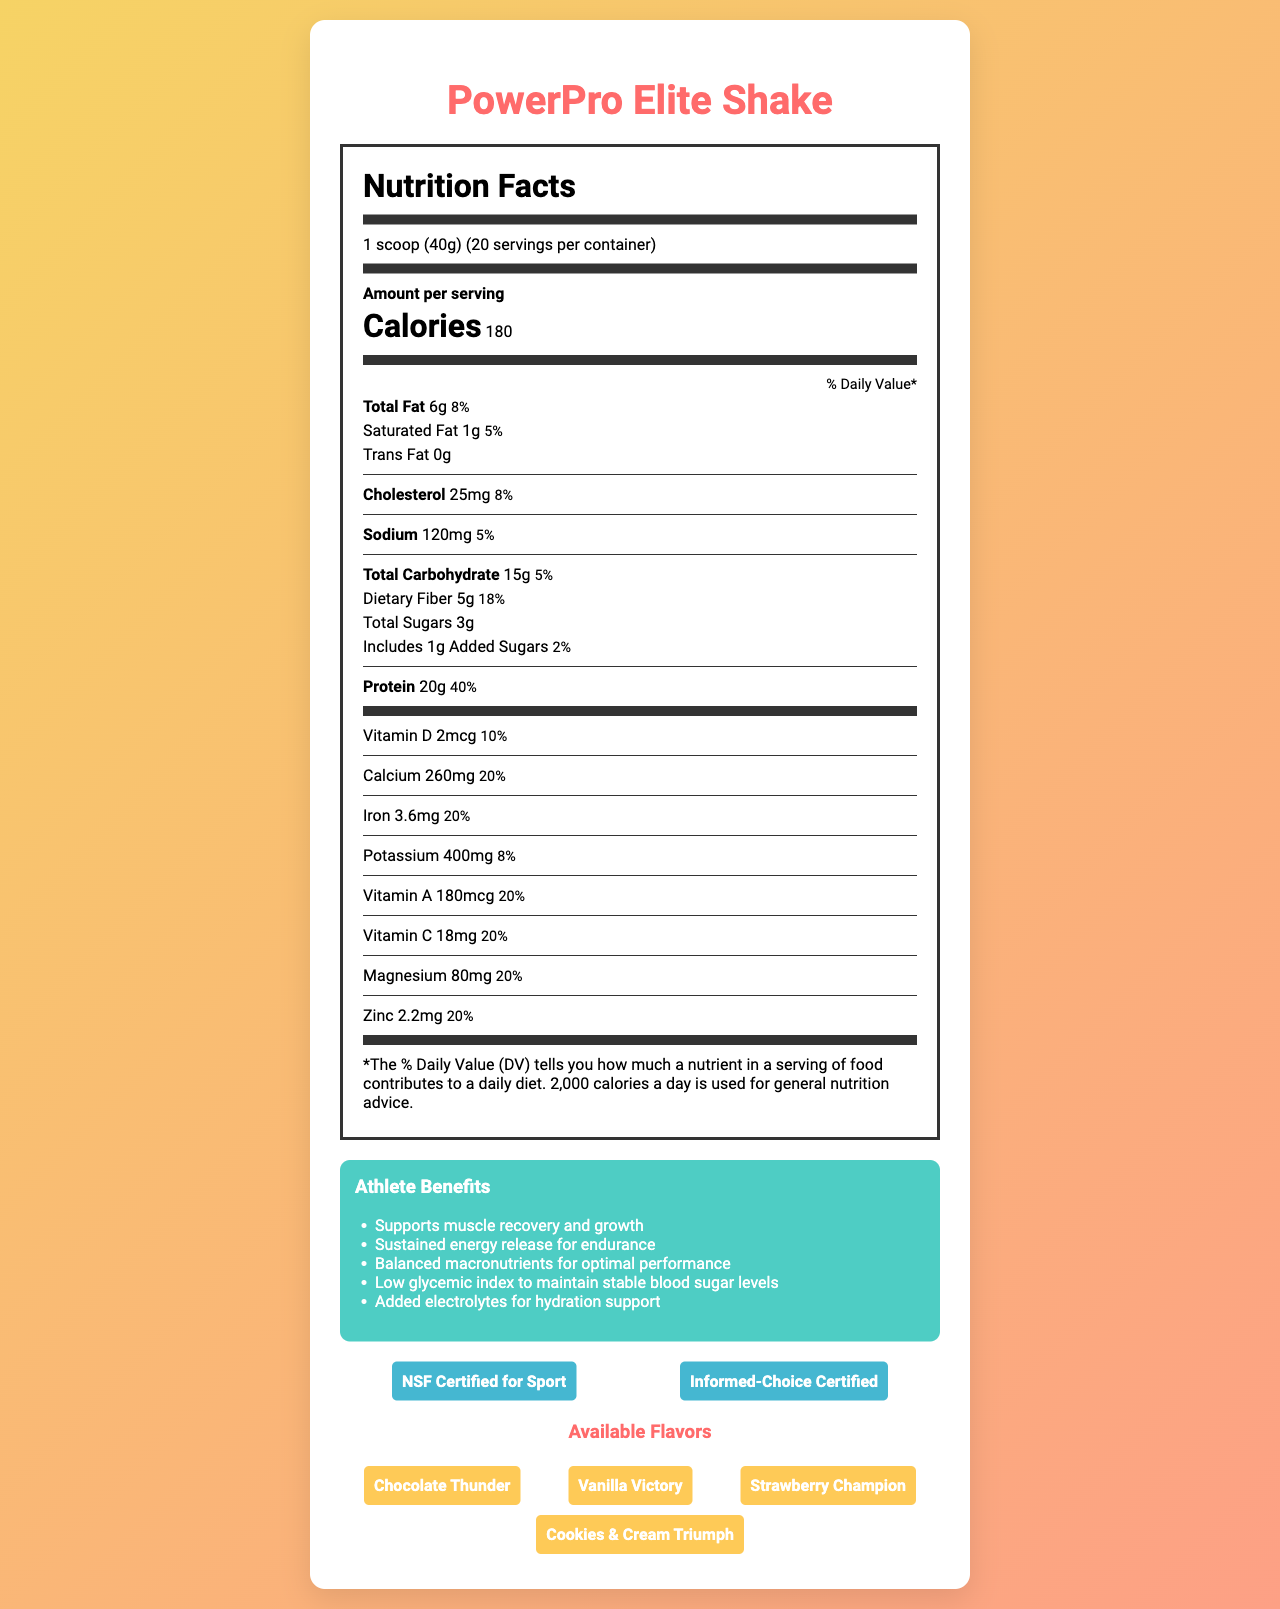what is the serving size of PowerPro Elite Shake? The serving size is explicitly mentioned as "1 scoop (40g)" in the document.
Answer: 1 scoop (40g) how many calories are there per serving of PowerPro Elite Shake? The document states that each serving contains 180 calories.
Answer: 180 calories what is the amount of dietary fiber in each serving? The nutrition label lists 5g of dietary fiber per serving.
Answer: 5g what allergens are present in the PowerPro Elite Shake? The allergen information section states that the product contains milk and is produced in a facility that processes soy, egg, tree nuts, and wheat.
Answer: Contains milk. Produced in a facility that also processes soy, egg, tree nuts, and wheat. how many servings are there per container? The document specifies that there are 20 servings per container.
Answer: 20 servings which benefits does the PowerPro Elite Shake provide for athletes? A. Supports muscle recovery B. Promotes weight gain C. Sustained energy release According to the athlete benefits section, the shake supports muscle recovery and growth, and sustains energy release for endurance. It does not mention promoting weight gain.
Answer: A. Supports muscle recovery C. Sustained energy release what is the daily value percentage of protein per serving? A. 20% B. 30% C. 40% D. 50% The document shows that the daily value percentage of protein per serving is 40%.
Answer: C. 40% does the PowerPro Elite Shake contain any artificial sweeteners? The listed ingredients include stevia leaf extract, which is a natural sweetener, but do not mention any artificial sweeteners.
Answer: No describe the main idea of the document. The document serves to inform readers about the nutritional content and benefits of the PowerPro Elite Shake, emphasizing its balanced macronutrients, low glycemic index, and suitability for athletic performance.
Answer: The document provides detailed nutritional information for the PowerPro Elite Shake, including its ingredients, serving size, calorie content, macronutrients, vitamins, and minerals. It highlights the benefits for athletes, allergen information, flavors available, and certifications. what is the source of the protein in the PowerPro Elite Shake? The ingredients list explicitly mentions "Whey protein isolate" and "Pea protein" as the sources of protein.
Answer: Whey protein isolate and Pea protein how much magnesium is there in one serving of this shake? The nutrition label indicates that there is 80mg of magnesium per serving.
Answer: 80mg what is the glycemic index of the PowerPro Elite Shake? The document lists the glycemic index as 28.
Answer: 28 is the PowerPro Elite Shake NSF Certified for Sport? The certifications section includes "NSF Certified for Sport."
Answer: Yes what is the main flavoring agent used in PowerPro Elite Shake? The document lists "Natural flavors" but does not specify the main agent used.
Answer: I don't know which vitamins in the shake contribute 20% of the daily value per serving? The nutrition label shows that both Vitamin A and Vitamin C contribute 20% of the daily value per serving.
Answer: Vitamin A, Vitamin C 